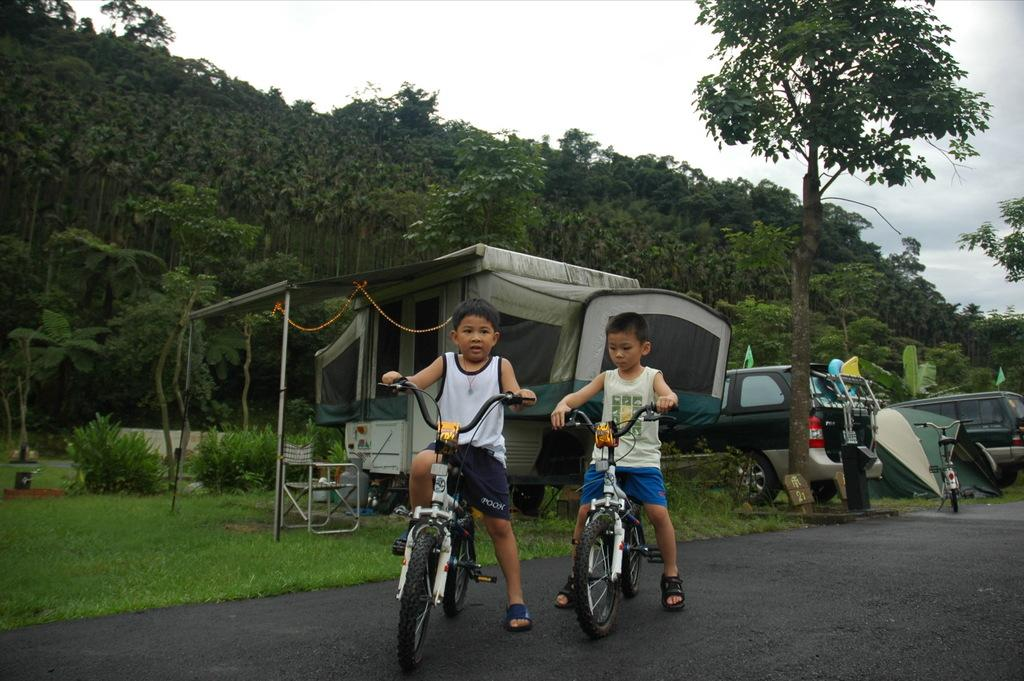How many children are in the image? There are two children in the image. What are the children holding in the image? The children are holding a bicycle. Where are the children located in the image? The children are on the road. What can be seen in the background of the image? There are trees visible in the background, and at least one vehicle can be seen as well. What type of art can be seen hanging on the wall in the image? There is no wall or art present in the image; it features two children holding a bicycle on the road. 